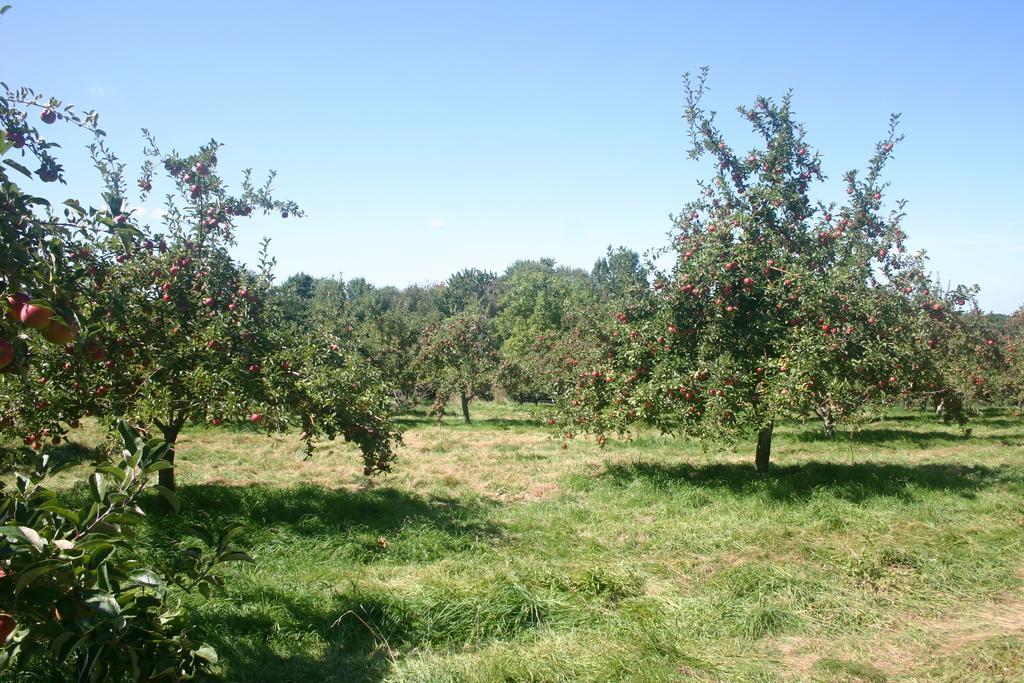Describe this image in one or two sentences. In this picture there is grassland at the bottom side of the image and there are trees around the area of the image. 